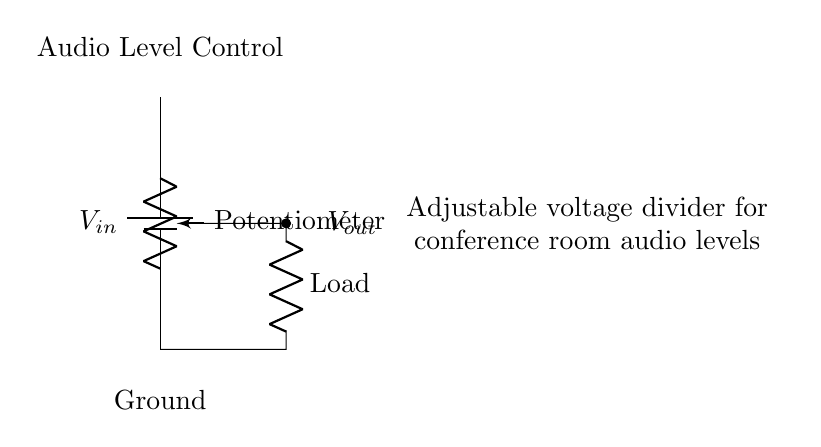What is the power supply voltage in this circuit? The voltage supply labeled as V_in is typically the input voltage that goes into the potentiometer in a voltage divider circuit. The exact value is not specified in the diagram provided, but it's an essential component of the circuit.
Answer: V_in What is the role of the potentiometer in this circuit? The potentiometer, labeled as "Potentiometer," acts as an adjustable resistor that divides the input voltage, allowing for varying levels of output voltage based on its position. This adjustable feature is vital for controlling the audio levels.
Answer: Audio Level Control What does the output voltage connect to? The output represented as V_out is connected to a load resistor, which in this context is likely part of the audio system where the adjusted voltage level will be applied. The output connection is marked with a short line leading to the load.
Answer: Load How can the audio level be adjusted in this circuit? The audio level can be adjusted by turning the potentiometer, which changes the resistance in the path of the voltage divider, thereby altering the amount of voltage that reaches the output connection. This physical adjustment enables easy control of audio levels in real-time.
Answer: By adjusting the potentiometer What happens when the potentiometer is turned fully clockwise? When the potentiometer is turned fully clockwise, it typically allows maximum current to pass through to the output, which could result in the maximum output voltage, likely close to V_in. Depending on the setup, this would maximize the audio level.
Answer: Maximum output voltage What is the purpose of the labeled ground in the circuit? The labeled ground in the circuit serves as a reference point for all voltage levels and provides a return path for current. It is essential for establishing a common reference voltage in electrical circuits, ensuring proper function of the audio system.
Answer: Reference point for voltage 